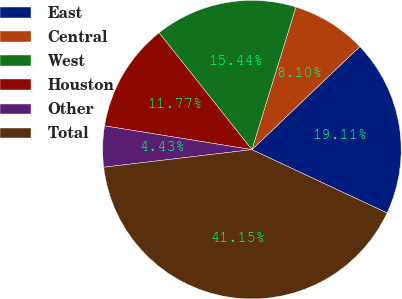Convert chart to OTSL. <chart><loc_0><loc_0><loc_500><loc_500><pie_chart><fcel>East<fcel>Central<fcel>West<fcel>Houston<fcel>Other<fcel>Total<nl><fcel>19.11%<fcel>8.1%<fcel>15.44%<fcel>11.77%<fcel>4.43%<fcel>41.15%<nl></chart> 